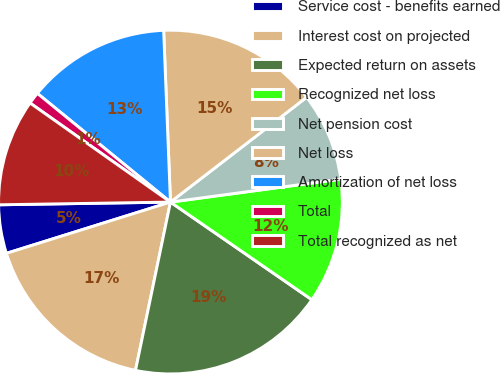<chart> <loc_0><loc_0><loc_500><loc_500><pie_chart><fcel>Service cost - benefits earned<fcel>Interest cost on projected<fcel>Expected return on assets<fcel>Recognized net loss<fcel>Net pension cost<fcel>Net loss<fcel>Amortization of net loss<fcel>Total<fcel>Total recognized as net<nl><fcel>4.57%<fcel>16.92%<fcel>18.64%<fcel>11.75%<fcel>8.31%<fcel>15.19%<fcel>13.47%<fcel>1.12%<fcel>10.03%<nl></chart> 